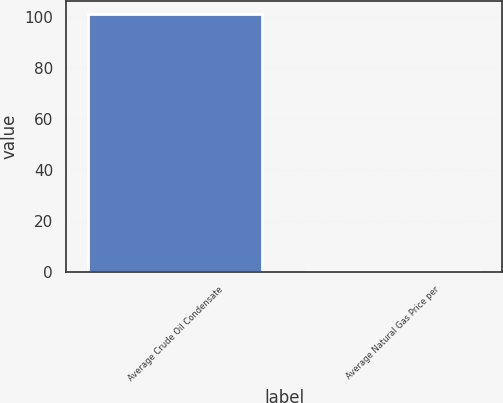Convert chart. <chart><loc_0><loc_0><loc_500><loc_500><bar_chart><fcel>Average Crude Oil Condensate<fcel>Average Natural Gas Price per<nl><fcel>100.97<fcel>0.25<nl></chart> 